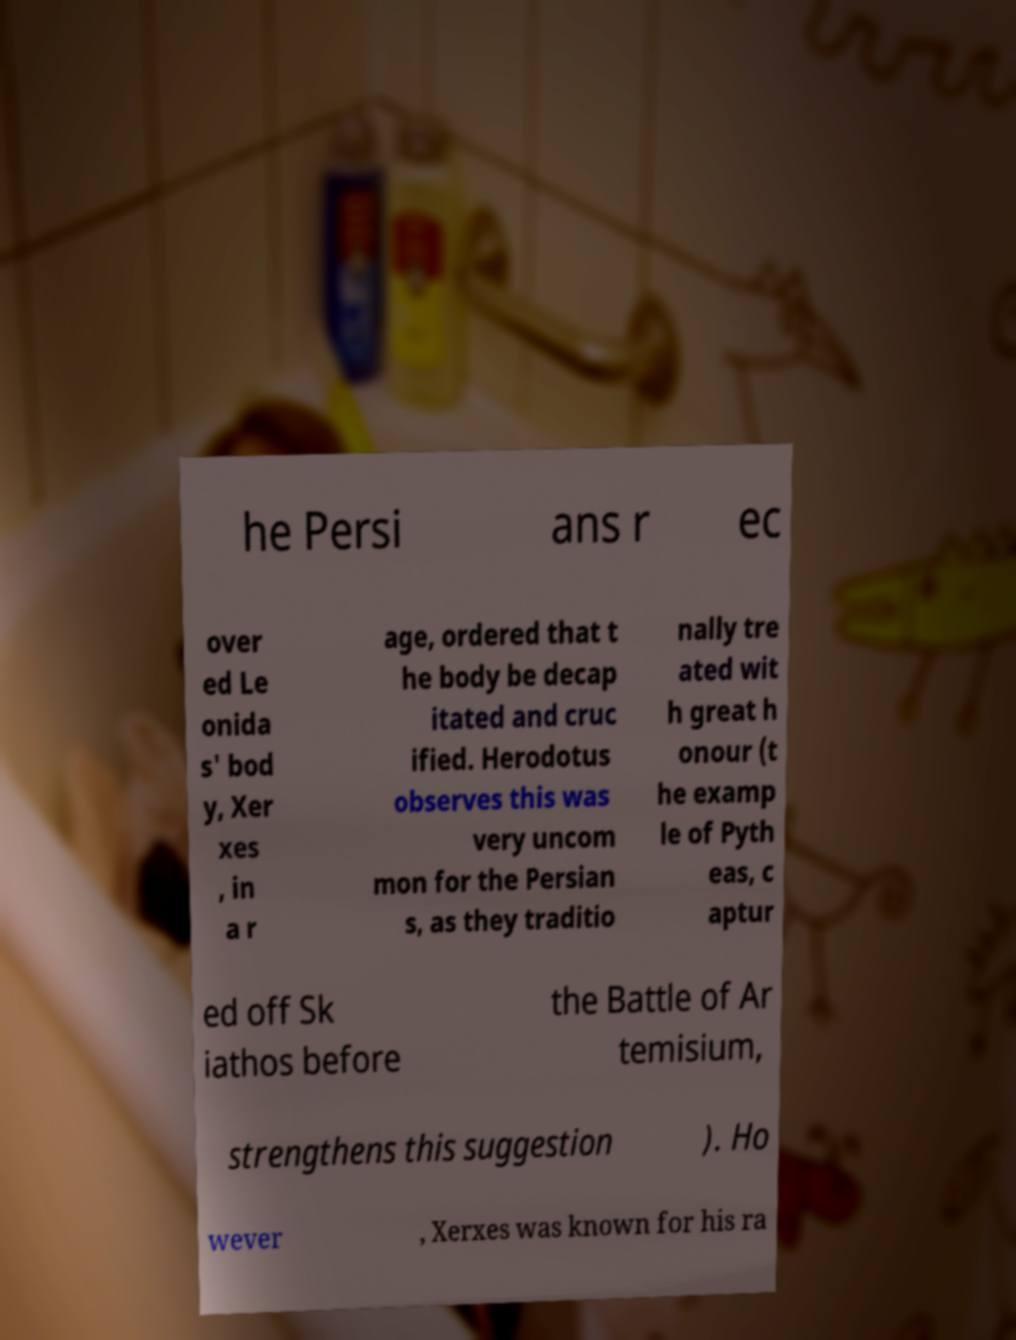Could you assist in decoding the text presented in this image and type it out clearly? he Persi ans r ec over ed Le onida s' bod y, Xer xes , in a r age, ordered that t he body be decap itated and cruc ified. Herodotus observes this was very uncom mon for the Persian s, as they traditio nally tre ated wit h great h onour (t he examp le of Pyth eas, c aptur ed off Sk iathos before the Battle of Ar temisium, strengthens this suggestion ). Ho wever , Xerxes was known for his ra 